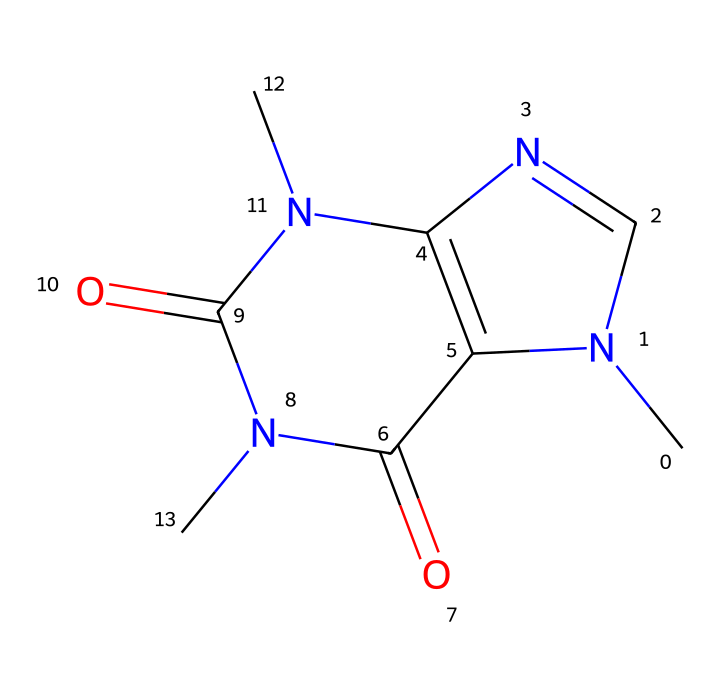What is the chemical name of this compound? The SMILES representation describes a structure known as caffeine, which is a common stimulant found in coffee. This can be confirmed by recognizing that the structure contains methyl and nitrogen groups typical of caffeine.
Answer: caffeine How many nitrogen atoms are present in this structure? By inspecting the SMILES representation, we see there are three distinct nitrogen atoms (N). Counting these gives the total number of nitrogen atoms as three.
Answer: three What type of bonds are primarily present in caffeine? The structure indicates the presence of covalent bonds connecting the different atoms, particularly between carbon and nitrogen. This can be inferred by the connections shown in the SMILES notation.
Answer: covalent bonds How many rings are present in the chemical structure? Analyzing the structure leads to the conclusion that caffeine contains two interconnected ring systems, which can be visually confirmed by looking at how the atoms are bonded together.
Answer: two What is the effect of caffeine on alertness? Caffeine is known to act as a central nervous system stimulant, increasing alertness by blocking adenosine receptors in the brain, which can be inferred from its action as a popular psychoactive substance.
Answer: increases alertness Is caffeine classified as an alkaloid? Caffeine contains nitrogen atoms and has effects on the nervous system, characteristics that classify it as an alkaloid. This classification can be confirmed by its structure and psychoactive properties.
Answer: yes What functional groups are notably present in caffeine? The prominent functional groups in caffeine include the methyl groups (–CH3) and amine groups (–NH). Identifying these from the structure helps establish the presence of these specific functional groups.
Answer: methyl and amine groups 